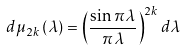Convert formula to latex. <formula><loc_0><loc_0><loc_500><loc_500>d \mu _ { 2 k } \left ( \lambda \right ) = \left ( \frac { \sin \pi \lambda } { \pi \lambda } \right ) ^ { 2 k } d \lambda</formula> 